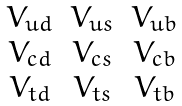<formula> <loc_0><loc_0><loc_500><loc_500>\begin{matrix} V _ { u d } & V _ { u s } & V _ { u b } \\ V _ { c d } & V _ { c s } & V _ { c b } \\ V _ { t d } & V _ { t s } & V _ { t b } \\ \end{matrix}</formula> 